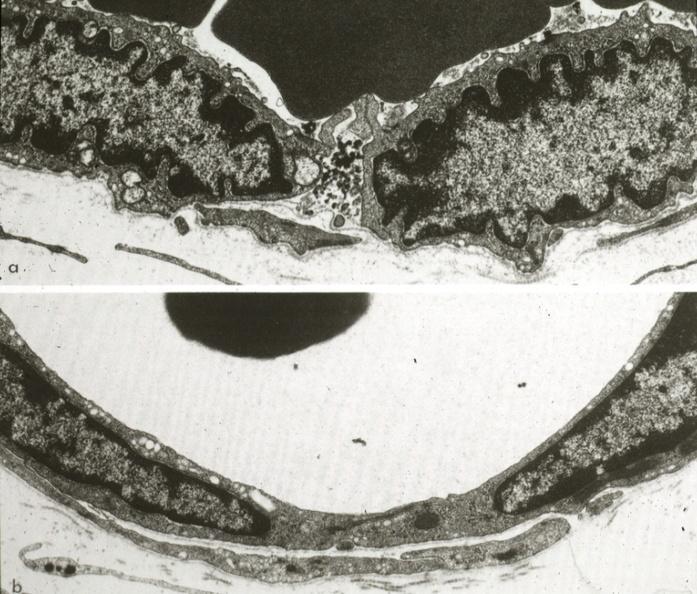s capillary present?
Answer the question using a single word or phrase. Yes 